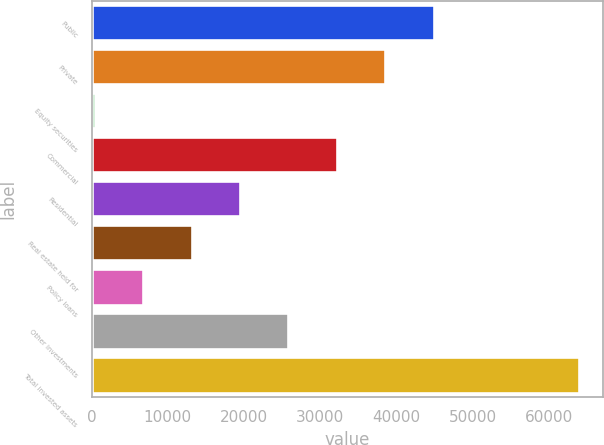Convert chart. <chart><loc_0><loc_0><loc_500><loc_500><bar_chart><fcel>Public<fcel>Private<fcel>Equity securities<fcel>Commercial<fcel>Residential<fcel>Real estate held for<fcel>Policy loans<fcel>Other investments<fcel>Total invested assets<nl><fcel>44886.2<fcel>38536.1<fcel>435.5<fcel>32186<fcel>19485.8<fcel>13135.7<fcel>6785.6<fcel>25835.9<fcel>63936.5<nl></chart> 